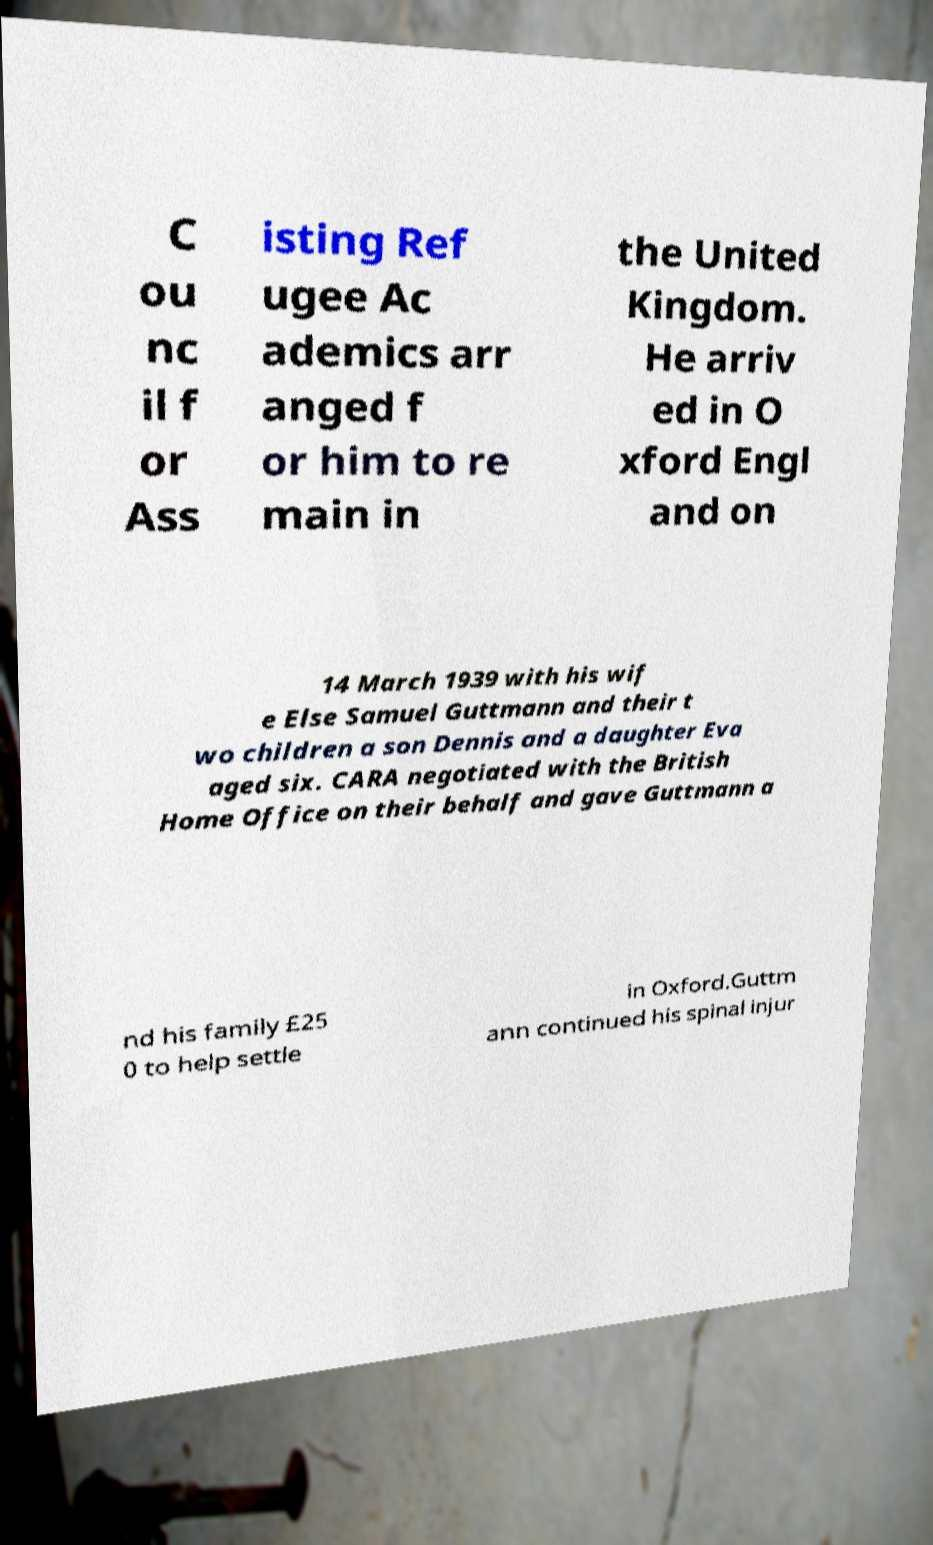Can you read and provide the text displayed in the image?This photo seems to have some interesting text. Can you extract and type it out for me? C ou nc il f or Ass isting Ref ugee Ac ademics arr anged f or him to re main in the United Kingdom. He arriv ed in O xford Engl and on 14 March 1939 with his wif e Else Samuel Guttmann and their t wo children a son Dennis and a daughter Eva aged six. CARA negotiated with the British Home Office on their behalf and gave Guttmann a nd his family £25 0 to help settle in Oxford.Guttm ann continued his spinal injur 